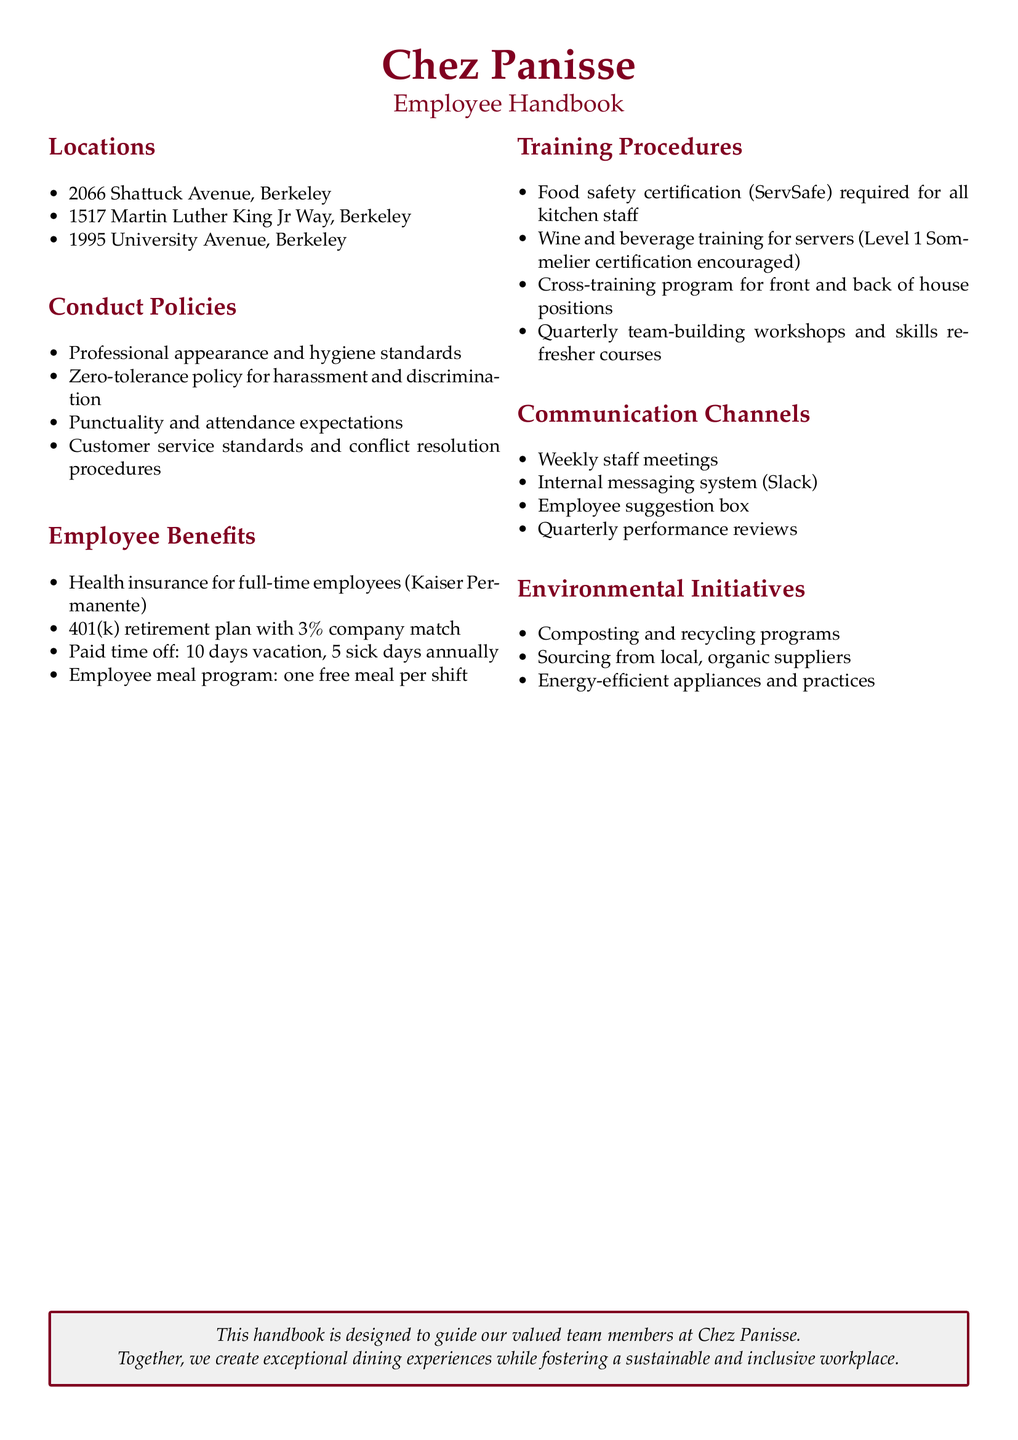What are the locations of Chez Panisse? The locations are listed in the document, detailing their addresses in Berkeley.
Answer: 2066 Shattuck Avenue, 1517 Martin Luther King Jr Way, 1995 University Avenue What is the health insurance provider for full-time employees? The document specifies that Kaiser Permanente provides health insurance for full-time employees.
Answer: Kaiser Permanente How many vacation days do employees receive annually? The document states that employees are entitled to 10 days of vacation per year.
Answer: 10 days What is the policy on harassment? The document mentions a zero-tolerance policy for harassment and discrimination.
Answer: Zero-tolerance How often are performance reviews conducted? The document indicates that performance reviews take place quarterly.
Answer: Quarterly What certification is required for kitchen staff? The document specifies food safety certification (ServSafe) as a requirement for all kitchen staff.
Answer: ServSafe What training program is encouraged for servers? The document suggests that Level 1 Sommelier certification is encouraged for servers.
Answer: Level 1 Sommelier certification What sustainability initiatives does Chez Panisse implement? The document lists several environmental initiatives that the restaurant follows to ensure sustainability.
Answer: Composting and recycling programs, Sourcing from local, organic suppliers, Energy-efficient appliances and practices What is the employee meal benefit provided? The document states that each employee receives one free meal per shift.
Answer: One free meal per shift 